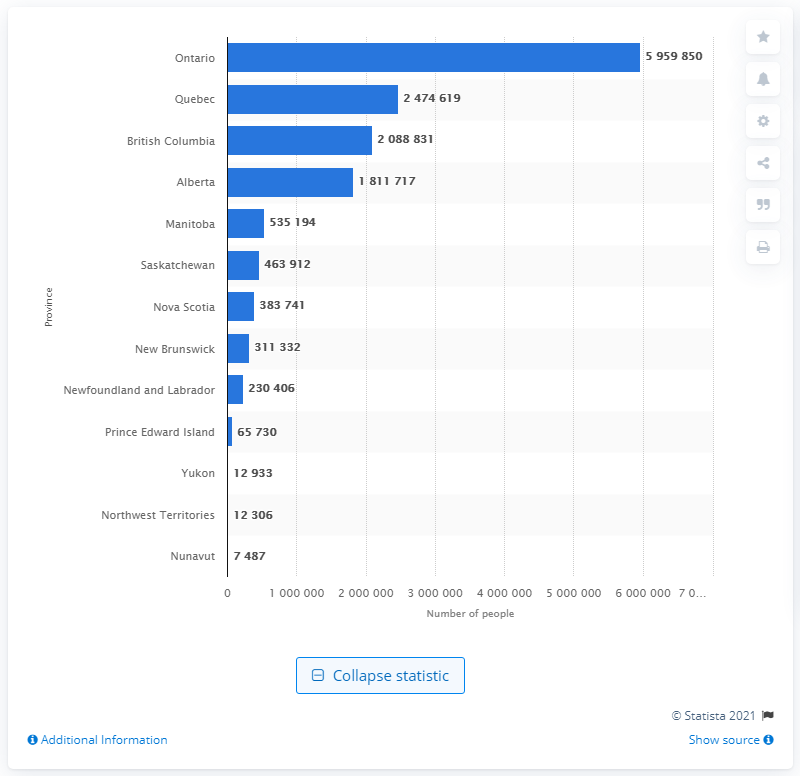Point out several critical features in this image. In 2020, there were approximately 5959850 married individuals living in Ontario. In 2020, the province of Ontario had the highest number of married individuals living within its borders. 